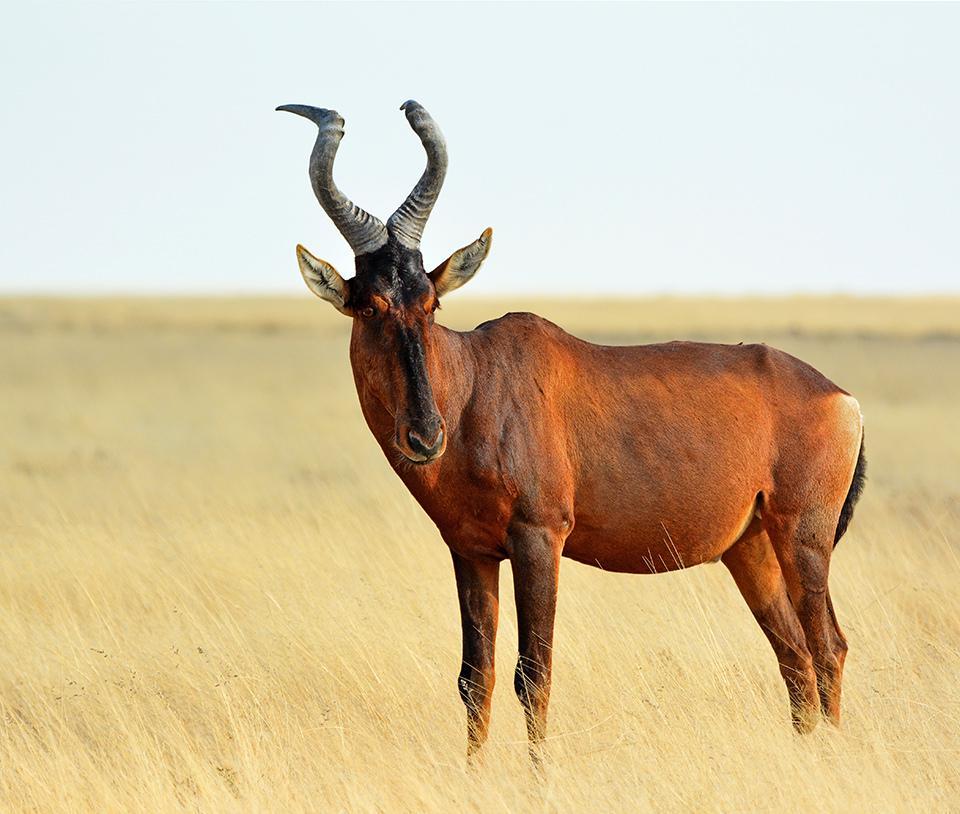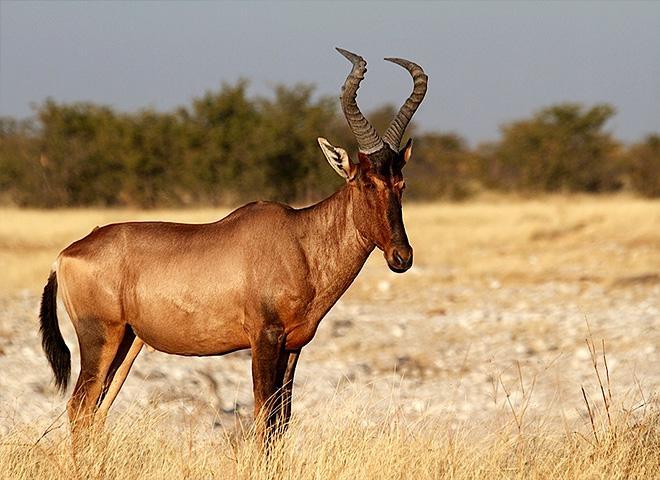The first image is the image on the left, the second image is the image on the right. Considering the images on both sides, is "One hooved animal has its body turned rightward and head facing forward, and the other stands with head and body in profile." valid? Answer yes or no. No. The first image is the image on the left, the second image is the image on the right. For the images displayed, is the sentence "There are two antelopes in the image pair, both facing right." factually correct? Answer yes or no. No. 